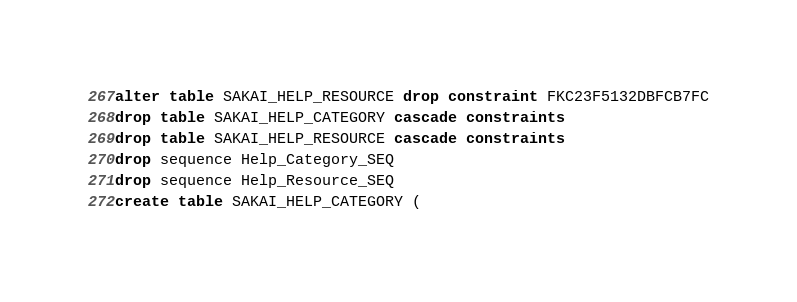<code> <loc_0><loc_0><loc_500><loc_500><_SQL_>alter table SAKAI_HELP_RESOURCE drop constraint FKC23F5132DBFCB7FC
drop table SAKAI_HELP_CATEGORY cascade constraints
drop table SAKAI_HELP_RESOURCE cascade constraints
drop sequence Help_Category_SEQ
drop sequence Help_Resource_SEQ
create table SAKAI_HELP_CATEGORY (</code> 